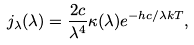<formula> <loc_0><loc_0><loc_500><loc_500>j _ { \lambda } ( \lambda ) = \frac { 2 c } { \lambda ^ { 4 } } \kappa ( \lambda ) e ^ { - h c / \lambda k T } ,</formula> 